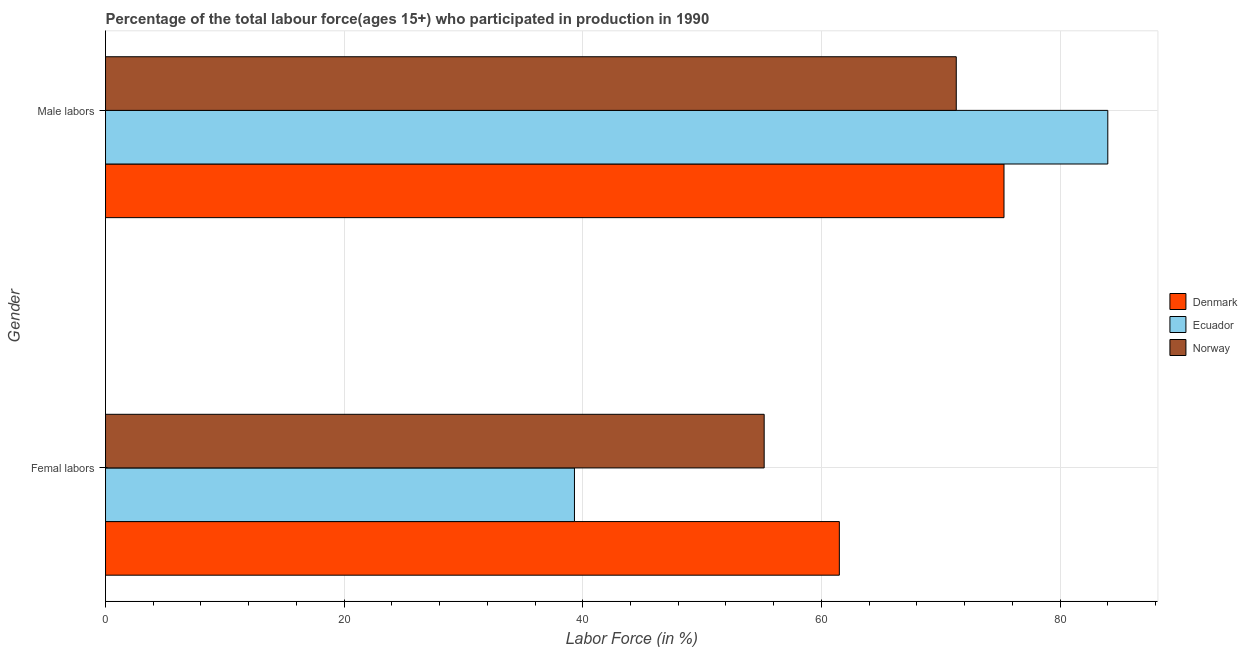How many different coloured bars are there?
Your response must be concise. 3. Are the number of bars on each tick of the Y-axis equal?
Offer a very short reply. Yes. How many bars are there on the 1st tick from the top?
Make the answer very short. 3. How many bars are there on the 1st tick from the bottom?
Provide a short and direct response. 3. What is the label of the 2nd group of bars from the top?
Offer a terse response. Femal labors. What is the percentage of female labor force in Norway?
Offer a very short reply. 55.2. Across all countries, what is the maximum percentage of female labor force?
Make the answer very short. 61.5. Across all countries, what is the minimum percentage of male labour force?
Ensure brevity in your answer.  71.3. In which country was the percentage of female labor force maximum?
Keep it short and to the point. Denmark. In which country was the percentage of female labor force minimum?
Keep it short and to the point. Ecuador. What is the total percentage of female labor force in the graph?
Your response must be concise. 156. What is the difference between the percentage of female labor force in Denmark and that in Ecuador?
Provide a short and direct response. 22.2. What is the difference between the percentage of male labour force in Norway and the percentage of female labor force in Ecuador?
Your answer should be very brief. 32. What is the average percentage of female labor force per country?
Ensure brevity in your answer.  52. What is the difference between the percentage of male labour force and percentage of female labor force in Norway?
Offer a very short reply. 16.1. What is the ratio of the percentage of female labor force in Norway to that in Ecuador?
Offer a very short reply. 1.4. Is the percentage of male labour force in Norway less than that in Denmark?
Your answer should be compact. Yes. What does the 1st bar from the bottom in Femal labors represents?
Ensure brevity in your answer.  Denmark. Are all the bars in the graph horizontal?
Your answer should be very brief. Yes. What is the difference between two consecutive major ticks on the X-axis?
Offer a terse response. 20. Does the graph contain grids?
Make the answer very short. Yes. Where does the legend appear in the graph?
Your answer should be compact. Center right. How are the legend labels stacked?
Keep it short and to the point. Vertical. What is the title of the graph?
Offer a terse response. Percentage of the total labour force(ages 15+) who participated in production in 1990. Does "Maldives" appear as one of the legend labels in the graph?
Your answer should be very brief. No. What is the label or title of the X-axis?
Provide a succinct answer. Labor Force (in %). What is the Labor Force (in %) of Denmark in Femal labors?
Keep it short and to the point. 61.5. What is the Labor Force (in %) of Ecuador in Femal labors?
Your answer should be very brief. 39.3. What is the Labor Force (in %) in Norway in Femal labors?
Your response must be concise. 55.2. What is the Labor Force (in %) of Denmark in Male labors?
Keep it short and to the point. 75.3. What is the Labor Force (in %) of Norway in Male labors?
Offer a very short reply. 71.3. Across all Gender, what is the maximum Labor Force (in %) in Denmark?
Give a very brief answer. 75.3. Across all Gender, what is the maximum Labor Force (in %) of Ecuador?
Your answer should be compact. 84. Across all Gender, what is the maximum Labor Force (in %) in Norway?
Your response must be concise. 71.3. Across all Gender, what is the minimum Labor Force (in %) of Denmark?
Your response must be concise. 61.5. Across all Gender, what is the minimum Labor Force (in %) of Ecuador?
Keep it short and to the point. 39.3. Across all Gender, what is the minimum Labor Force (in %) of Norway?
Your response must be concise. 55.2. What is the total Labor Force (in %) in Denmark in the graph?
Offer a terse response. 136.8. What is the total Labor Force (in %) in Ecuador in the graph?
Your response must be concise. 123.3. What is the total Labor Force (in %) in Norway in the graph?
Offer a very short reply. 126.5. What is the difference between the Labor Force (in %) in Denmark in Femal labors and that in Male labors?
Your answer should be very brief. -13.8. What is the difference between the Labor Force (in %) of Ecuador in Femal labors and that in Male labors?
Provide a short and direct response. -44.7. What is the difference between the Labor Force (in %) of Norway in Femal labors and that in Male labors?
Keep it short and to the point. -16.1. What is the difference between the Labor Force (in %) in Denmark in Femal labors and the Labor Force (in %) in Ecuador in Male labors?
Offer a very short reply. -22.5. What is the difference between the Labor Force (in %) in Ecuador in Femal labors and the Labor Force (in %) in Norway in Male labors?
Offer a terse response. -32. What is the average Labor Force (in %) in Denmark per Gender?
Your answer should be compact. 68.4. What is the average Labor Force (in %) of Ecuador per Gender?
Offer a very short reply. 61.65. What is the average Labor Force (in %) of Norway per Gender?
Provide a short and direct response. 63.25. What is the difference between the Labor Force (in %) in Denmark and Labor Force (in %) in Ecuador in Femal labors?
Your response must be concise. 22.2. What is the difference between the Labor Force (in %) of Ecuador and Labor Force (in %) of Norway in Femal labors?
Provide a succinct answer. -15.9. What is the difference between the Labor Force (in %) in Denmark and Labor Force (in %) in Ecuador in Male labors?
Make the answer very short. -8.7. What is the difference between the Labor Force (in %) in Denmark and Labor Force (in %) in Norway in Male labors?
Your answer should be compact. 4. What is the difference between the Labor Force (in %) of Ecuador and Labor Force (in %) of Norway in Male labors?
Offer a terse response. 12.7. What is the ratio of the Labor Force (in %) in Denmark in Femal labors to that in Male labors?
Ensure brevity in your answer.  0.82. What is the ratio of the Labor Force (in %) of Ecuador in Femal labors to that in Male labors?
Provide a short and direct response. 0.47. What is the ratio of the Labor Force (in %) in Norway in Femal labors to that in Male labors?
Ensure brevity in your answer.  0.77. What is the difference between the highest and the second highest Labor Force (in %) in Denmark?
Make the answer very short. 13.8. What is the difference between the highest and the second highest Labor Force (in %) of Ecuador?
Give a very brief answer. 44.7. What is the difference between the highest and the lowest Labor Force (in %) of Denmark?
Offer a terse response. 13.8. What is the difference between the highest and the lowest Labor Force (in %) of Ecuador?
Your response must be concise. 44.7. 